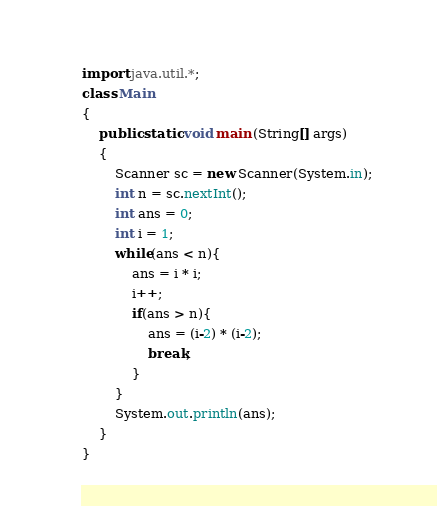Convert code to text. <code><loc_0><loc_0><loc_500><loc_500><_Java_>import java.util.*;
class Main
{
    public static void main (String[] args)
    {
        Scanner sc = new Scanner(System.in);
        int n = sc.nextInt();
        int ans = 0;
        int i = 1;
        while(ans < n){
            ans = i * i;
            i++;
            if(ans > n){
                ans = (i-2) * (i-2);
                break;
            }
        }
        System.out.println(ans);
    }
}</code> 